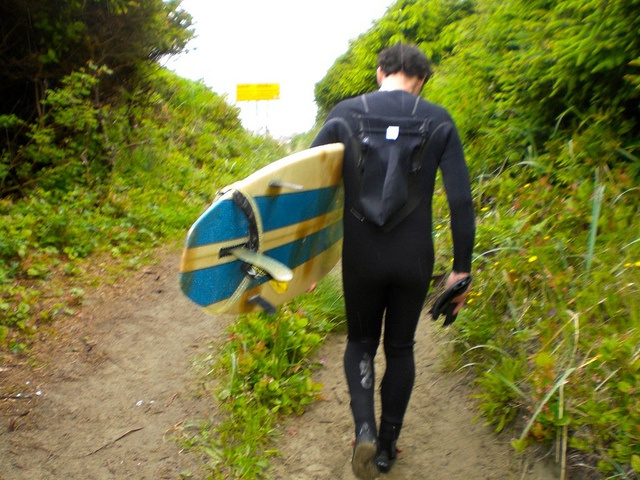Describe the objects in this image and their specific colors. I can see people in black, gray, darkgreen, and tan tones and surfboard in black, blue, tan, teal, and olive tones in this image. 